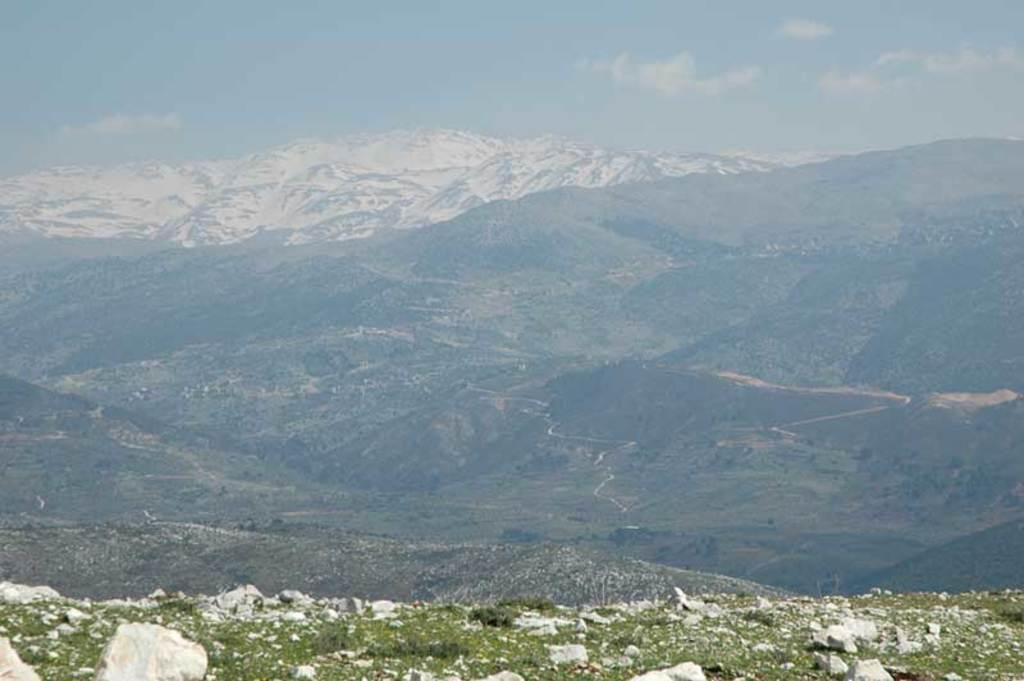What type of natural formation can be seen in the image? There are mountains in the image. What type of terrain is present in the image? There are rocks, snow, trees, bushes, plants, and grass in the image. What is visible at the top of the image? The sky is visible at the top of the image. What type of shirt is being used to hammer the waste in the image? There is no shirt, hammer, or waste present in the image. 